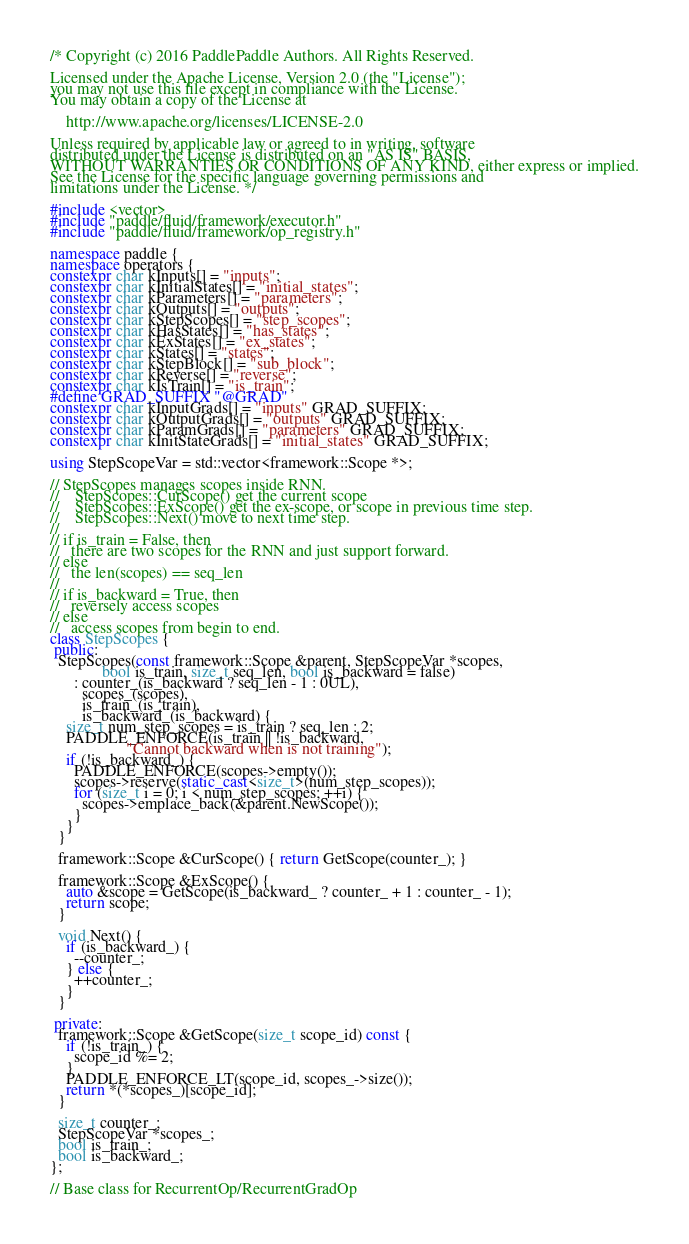Convert code to text. <code><loc_0><loc_0><loc_500><loc_500><_C++_>/* Copyright (c) 2016 PaddlePaddle Authors. All Rights Reserved.

Licensed under the Apache License, Version 2.0 (the "License");
you may not use this file except in compliance with the License.
You may obtain a copy of the License at

    http://www.apache.org/licenses/LICENSE-2.0

Unless required by applicable law or agreed to in writing, software
distributed under the License is distributed on an "AS IS" BASIS,
WITHOUT WARRANTIES OR CONDITIONS OF ANY KIND, either express or implied.
See the License for the specific language governing permissions and
limitations under the License. */

#include <vector>
#include "paddle/fluid/framework/executor.h"
#include "paddle/fluid/framework/op_registry.h"

namespace paddle {
namespace operators {
constexpr char kInputs[] = "inputs";
constexpr char kInitialStates[] = "initial_states";
constexpr char kParameters[] = "parameters";
constexpr char kOutputs[] = "outputs";
constexpr char kStepScopes[] = "step_scopes";
constexpr char kHasStates[] = "has_states";
constexpr char kExStates[] = "ex_states";
constexpr char kStates[] = "states";
constexpr char kStepBlock[] = "sub_block";
constexpr char kReverse[] = "reverse";
constexpr char kIsTrain[] = "is_train";
#define GRAD_SUFFIX "@GRAD"
constexpr char kInputGrads[] = "inputs" GRAD_SUFFIX;
constexpr char kOutputGrads[] = "outputs" GRAD_SUFFIX;
constexpr char kParamGrads[] = "parameters" GRAD_SUFFIX;
constexpr char kInitStateGrads[] = "initial_states" GRAD_SUFFIX;

using StepScopeVar = std::vector<framework::Scope *>;

// StepScopes manages scopes inside RNN.
//    StepScopes::CurScope() get the current scope
//    StepScopes::ExScope() get the ex-scope, or scope in previous time step.
//    StepScopes::Next() move to next time step.
//
// if is_train = False, then
//   there are two scopes for the RNN and just support forward.
// else
//   the len(scopes) == seq_len
//
// if is_backward = True, then
//   reversely access scopes
// else
//   access scopes from begin to end.
class StepScopes {
 public:
  StepScopes(const framework::Scope &parent, StepScopeVar *scopes,
             bool is_train, size_t seq_len, bool is_backward = false)
      : counter_(is_backward ? seq_len - 1 : 0UL),
        scopes_(scopes),
        is_train_(is_train),
        is_backward_(is_backward) {
    size_t num_step_scopes = is_train ? seq_len : 2;
    PADDLE_ENFORCE(is_train || !is_backward,
                   "Cannot backward when is not training");
    if (!is_backward_) {
      PADDLE_ENFORCE(scopes->empty());
      scopes->reserve(static_cast<size_t>(num_step_scopes));
      for (size_t i = 0; i < num_step_scopes; ++i) {
        scopes->emplace_back(&parent.NewScope());
      }
    }
  }

  framework::Scope &CurScope() { return GetScope(counter_); }

  framework::Scope &ExScope() {
    auto &scope = GetScope(is_backward_ ? counter_ + 1 : counter_ - 1);
    return scope;
  }

  void Next() {
    if (is_backward_) {
      --counter_;
    } else {
      ++counter_;
    }
  }

 private:
  framework::Scope &GetScope(size_t scope_id) const {
    if (!is_train_) {
      scope_id %= 2;
    }
    PADDLE_ENFORCE_LT(scope_id, scopes_->size());
    return *(*scopes_)[scope_id];
  }

  size_t counter_;
  StepScopeVar *scopes_;
  bool is_train_;
  bool is_backward_;
};

// Base class for RecurrentOp/RecurrentGradOp</code> 